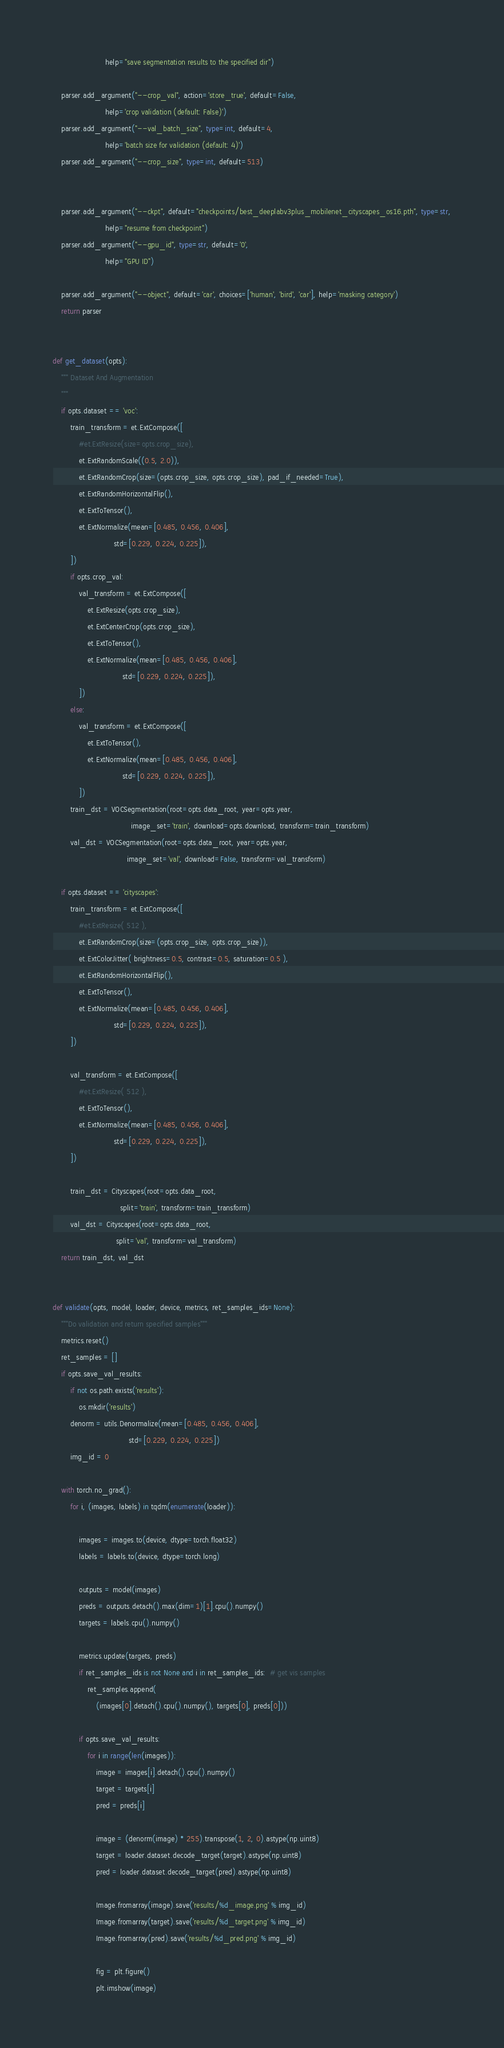Convert code to text. <code><loc_0><loc_0><loc_500><loc_500><_Python_>                        help="save segmentation results to the specified dir")

    parser.add_argument("--crop_val", action='store_true', default=False,
                        help='crop validation (default: False)')
    parser.add_argument("--val_batch_size", type=int, default=4,
                        help='batch size for validation (default: 4)')
    parser.add_argument("--crop_size", type=int, default=513)

    
    parser.add_argument("--ckpt", default="checkpoints/best_deeplabv3plus_mobilenet_cityscapes_os16.pth", type=str,
                        help="resume from checkpoint")
    parser.add_argument("--gpu_id", type=str, default='0',
                        help="GPU ID")

    parser.add_argument("--object", default='car', choices=['human', 'bird', 'car'], help='masking category')
    return parser


def get_dataset(opts):
    """ Dataset And Augmentation
    """
    if opts.dataset == 'voc':
        train_transform = et.ExtCompose([
            #et.ExtResize(size=opts.crop_size),
            et.ExtRandomScale((0.5, 2.0)),
            et.ExtRandomCrop(size=(opts.crop_size, opts.crop_size), pad_if_needed=True),
            et.ExtRandomHorizontalFlip(),
            et.ExtToTensor(),
            et.ExtNormalize(mean=[0.485, 0.456, 0.406],
                            std=[0.229, 0.224, 0.225]),
        ])
        if opts.crop_val:
            val_transform = et.ExtCompose([
                et.ExtResize(opts.crop_size),
                et.ExtCenterCrop(opts.crop_size),
                et.ExtToTensor(),
                et.ExtNormalize(mean=[0.485, 0.456, 0.406],
                                std=[0.229, 0.224, 0.225]),
            ])
        else:
            val_transform = et.ExtCompose([
                et.ExtToTensor(),
                et.ExtNormalize(mean=[0.485, 0.456, 0.406],
                                std=[0.229, 0.224, 0.225]),
            ])
        train_dst = VOCSegmentation(root=opts.data_root, year=opts.year,
                                    image_set='train', download=opts.download, transform=train_transform)
        val_dst = VOCSegmentation(root=opts.data_root, year=opts.year,
                                  image_set='val', download=False, transform=val_transform)

    if opts.dataset == 'cityscapes':
        train_transform = et.ExtCompose([
            #et.ExtResize( 512 ),
            et.ExtRandomCrop(size=(opts.crop_size, opts.crop_size)),
            et.ExtColorJitter( brightness=0.5, contrast=0.5, saturation=0.5 ),
            et.ExtRandomHorizontalFlip(),
            et.ExtToTensor(),
            et.ExtNormalize(mean=[0.485, 0.456, 0.406],
                            std=[0.229, 0.224, 0.225]),
        ])

        val_transform = et.ExtCompose([
            #et.ExtResize( 512 ),
            et.ExtToTensor(),
            et.ExtNormalize(mean=[0.485, 0.456, 0.406],
                            std=[0.229, 0.224, 0.225]),
        ])

        train_dst = Cityscapes(root=opts.data_root,
                               split='train', transform=train_transform)
        val_dst = Cityscapes(root=opts.data_root,
                             split='val', transform=val_transform)
    return train_dst, val_dst


def validate(opts, model, loader, device, metrics, ret_samples_ids=None):
    """Do validation and return specified samples"""
    metrics.reset()
    ret_samples = []
    if opts.save_val_results:
        if not os.path.exists('results'):
            os.mkdir('results')
        denorm = utils.Denormalize(mean=[0.485, 0.456, 0.406], 
                                   std=[0.229, 0.224, 0.225])
        img_id = 0

    with torch.no_grad():
        for i, (images, labels) in tqdm(enumerate(loader)):
            
            images = images.to(device, dtype=torch.float32)
            labels = labels.to(device, dtype=torch.long)

            outputs = model(images)
            preds = outputs.detach().max(dim=1)[1].cpu().numpy()
            targets = labels.cpu().numpy()

            metrics.update(targets, preds)
            if ret_samples_ids is not None and i in ret_samples_ids:  # get vis samples
                ret_samples.append(
                    (images[0].detach().cpu().numpy(), targets[0], preds[0]))

            if opts.save_val_results:
                for i in range(len(images)):
                    image = images[i].detach().cpu().numpy()
                    target = targets[i]
                    pred = preds[i]

                    image = (denorm(image) * 255).transpose(1, 2, 0).astype(np.uint8)
                    target = loader.dataset.decode_target(target).astype(np.uint8)
                    pred = loader.dataset.decode_target(pred).astype(np.uint8)

                    Image.fromarray(image).save('results/%d_image.png' % img_id)
                    Image.fromarray(target).save('results/%d_target.png' % img_id)
                    Image.fromarray(pred).save('results/%d_pred.png' % img_id)

                    fig = plt.figure()
                    plt.imshow(image)</code> 